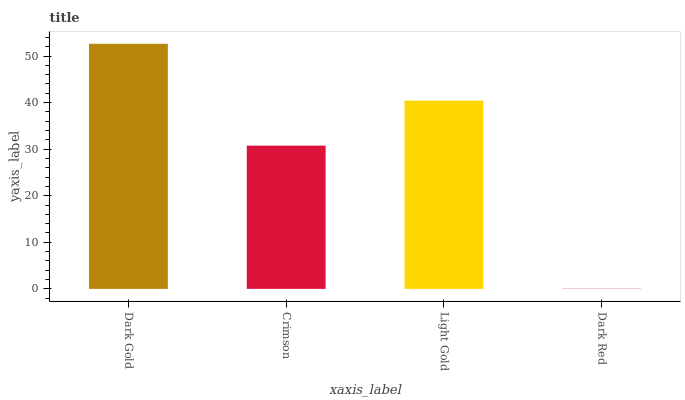Is Dark Red the minimum?
Answer yes or no. Yes. Is Dark Gold the maximum?
Answer yes or no. Yes. Is Crimson the minimum?
Answer yes or no. No. Is Crimson the maximum?
Answer yes or no. No. Is Dark Gold greater than Crimson?
Answer yes or no. Yes. Is Crimson less than Dark Gold?
Answer yes or no. Yes. Is Crimson greater than Dark Gold?
Answer yes or no. No. Is Dark Gold less than Crimson?
Answer yes or no. No. Is Light Gold the high median?
Answer yes or no. Yes. Is Crimson the low median?
Answer yes or no. Yes. Is Dark Gold the high median?
Answer yes or no. No. Is Dark Red the low median?
Answer yes or no. No. 